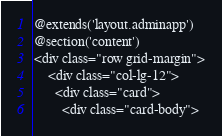Convert code to text. <code><loc_0><loc_0><loc_500><loc_500><_PHP_>@extends('layout.adminapp')
@section('content')
<div class="row grid-margin">
    <div class="col-lg-12">
      <div class="card">
        <div class="card-body"></code> 